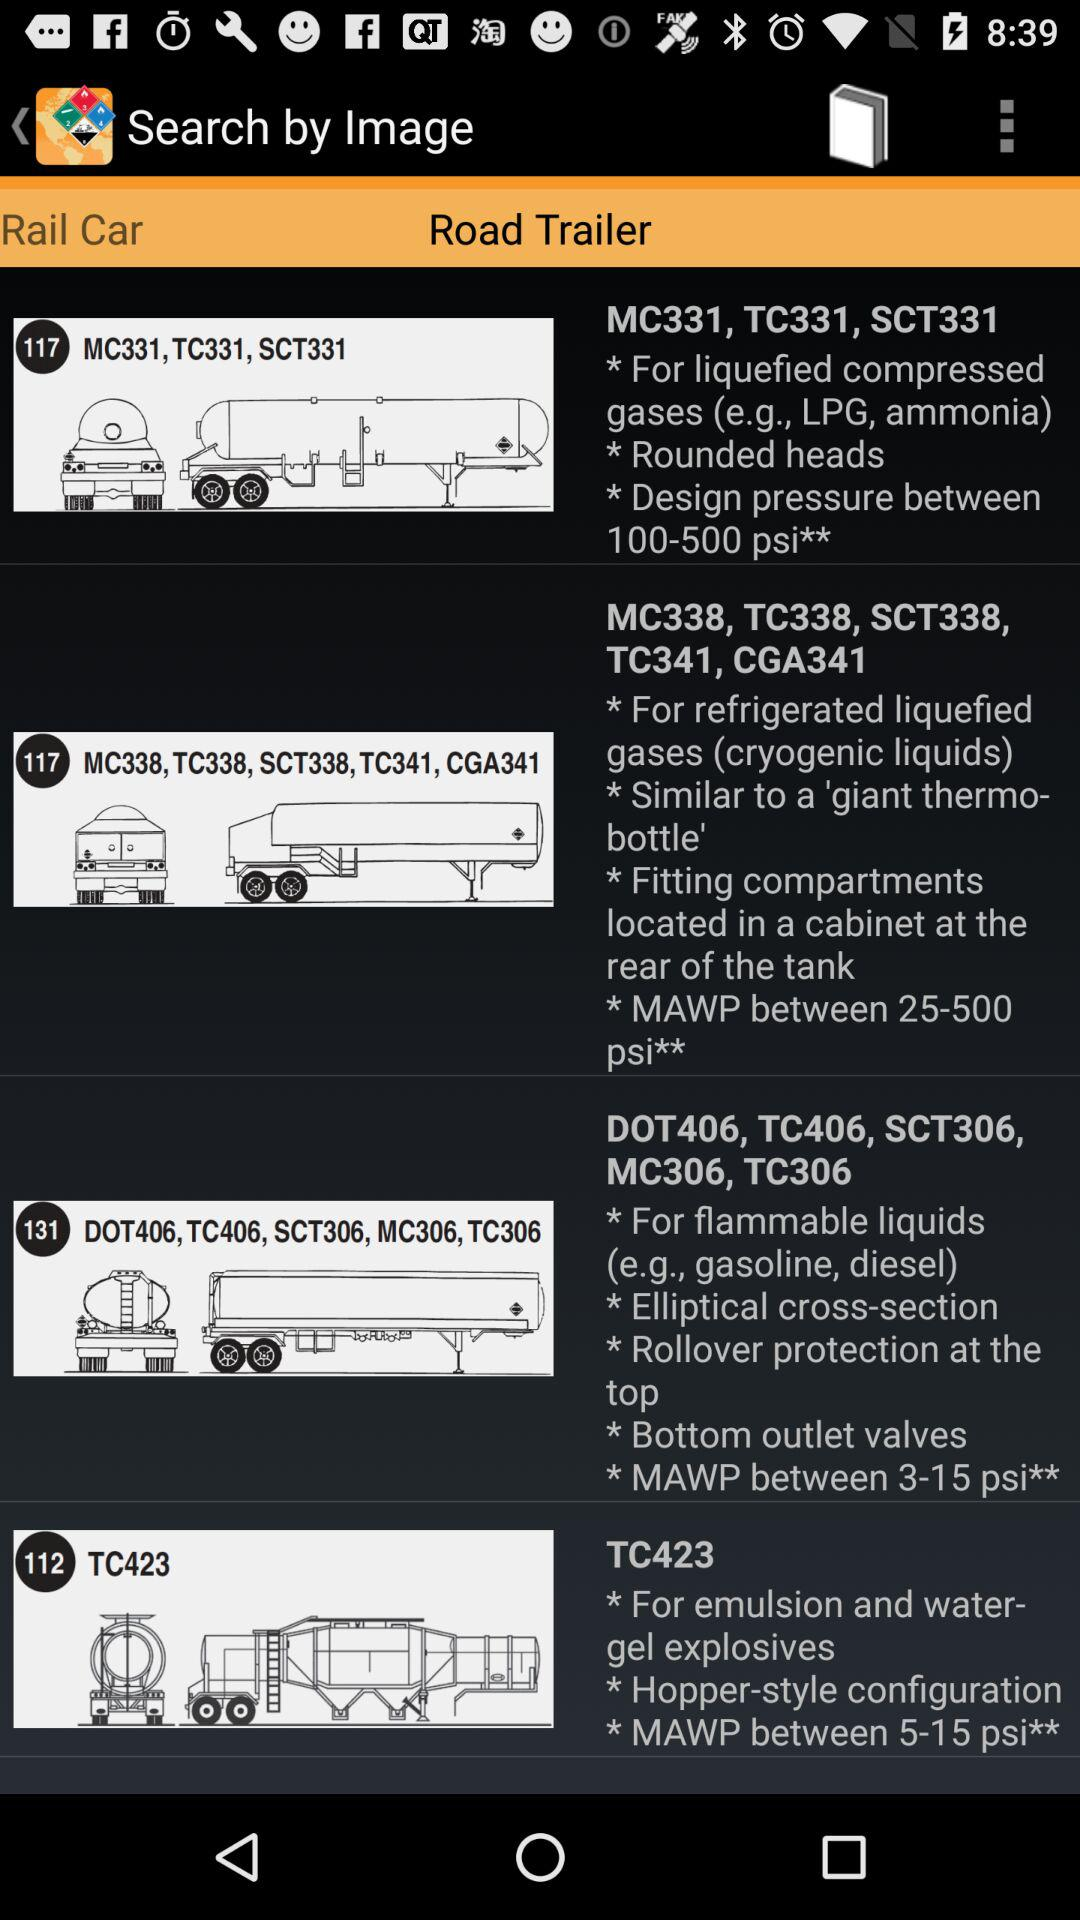Which tab has been selected? The selected tab is "Road Trailer". 